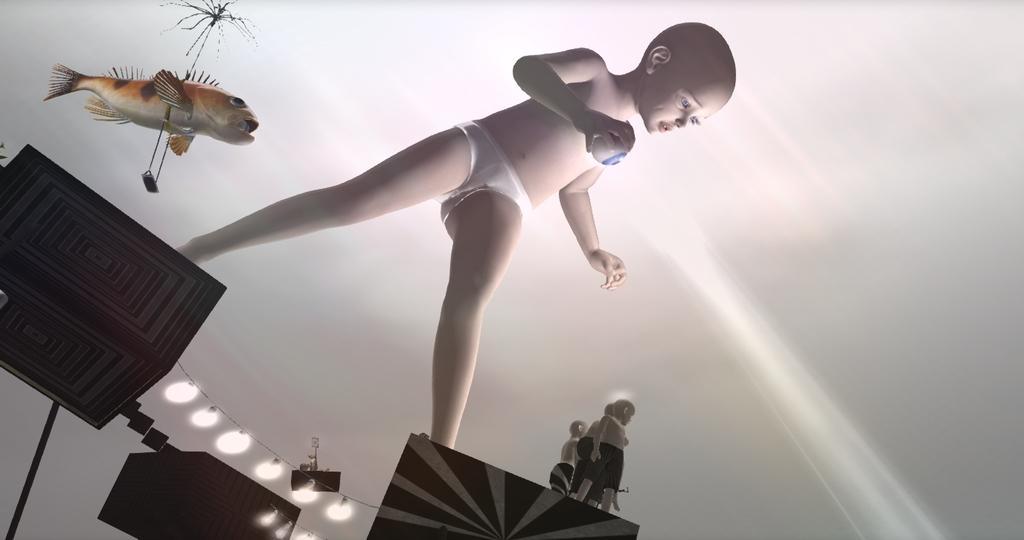Describe this image in one or two sentences. This is an animated image, in this image there is a boy standing on boxes and there is a fish lights and toys. 